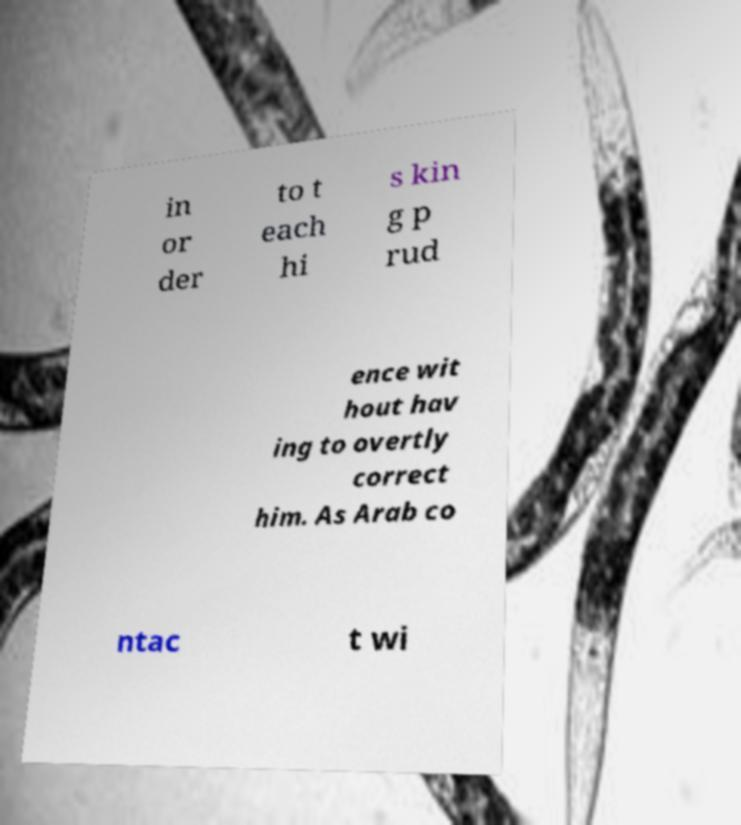I need the written content from this picture converted into text. Can you do that? in or der to t each hi s kin g p rud ence wit hout hav ing to overtly correct him. As Arab co ntac t wi 